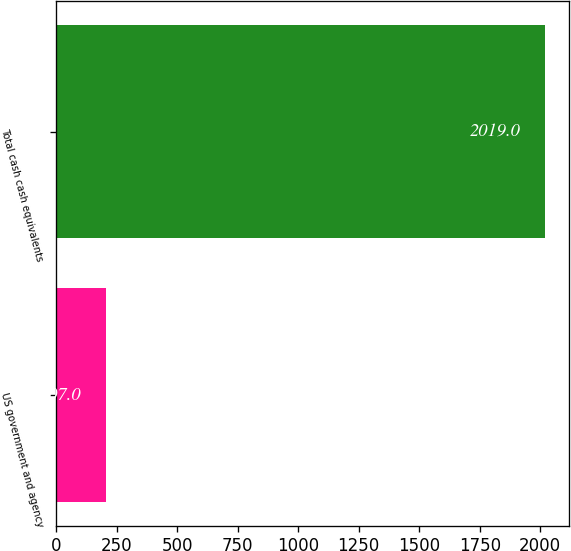<chart> <loc_0><loc_0><loc_500><loc_500><bar_chart><fcel>US government and agency<fcel>Total cash cash equivalents<nl><fcel>207<fcel>2019<nl></chart> 